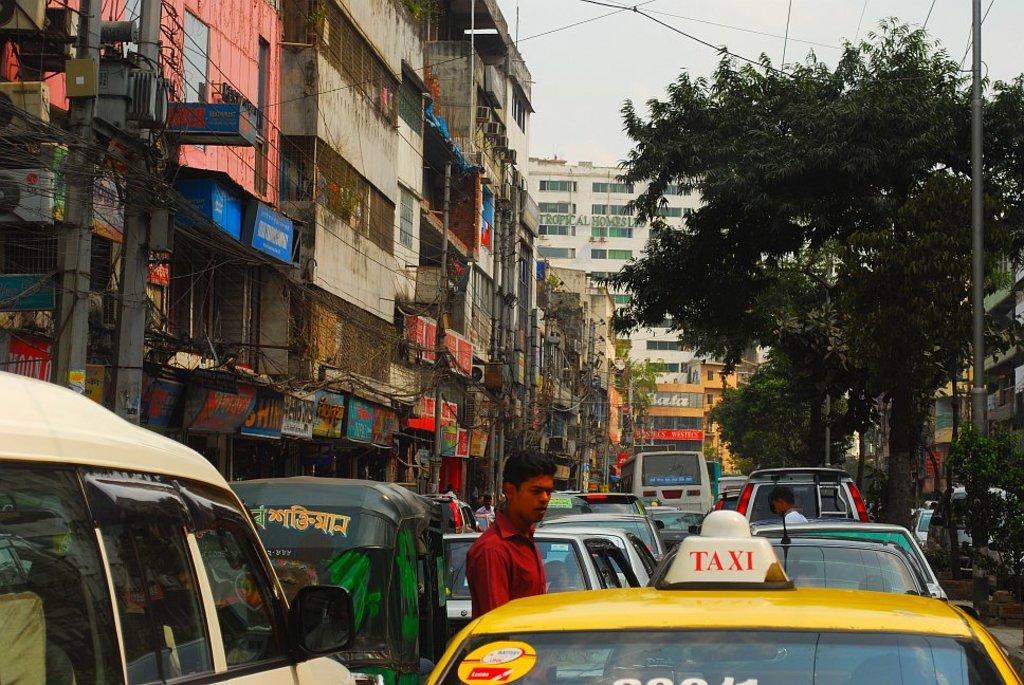What kind of vehicle is the yellow car?
Provide a succinct answer. Taxi. 